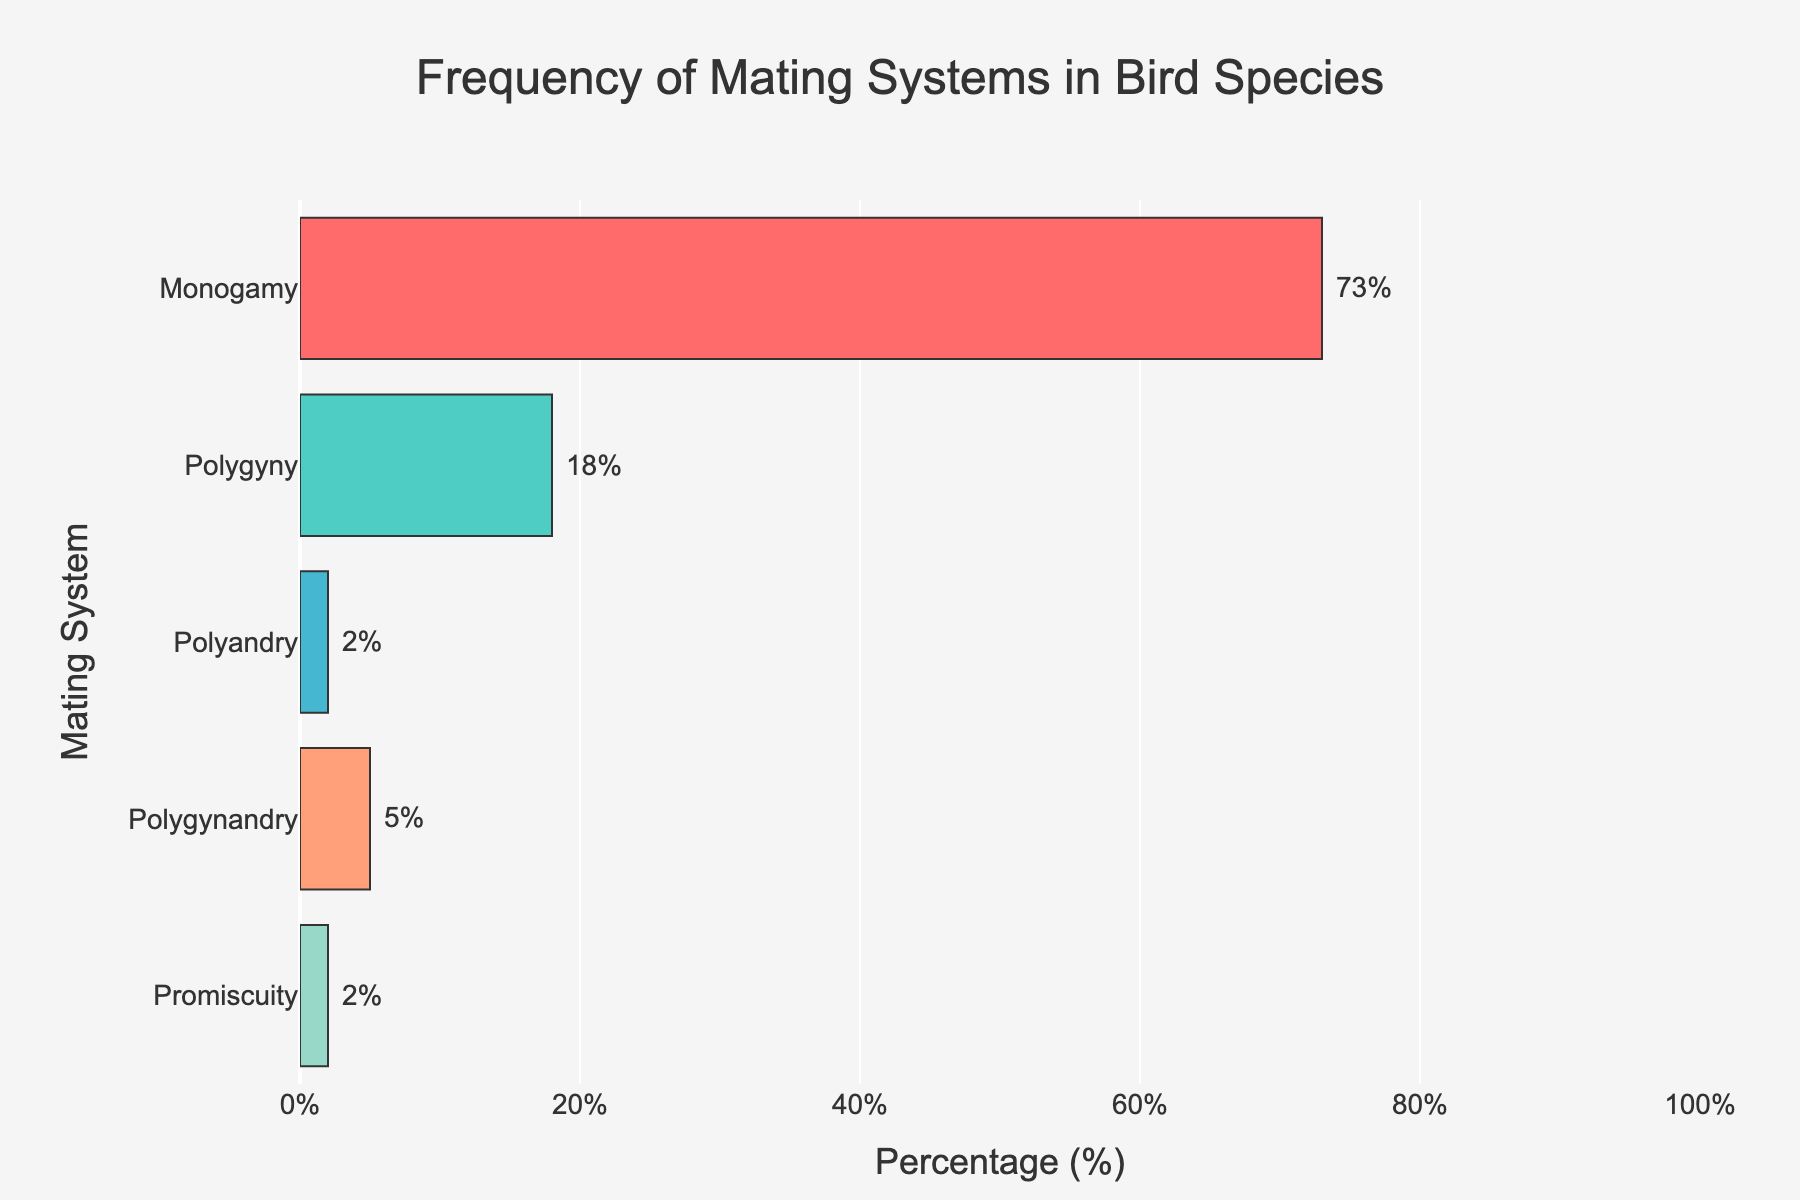what is the title of the plot? The title of the plot is positioned at the top and clearly states what the plot is about.
Answer: Frequency of Mating Systems in Bird Species What percentage of bird species practice monogamy? Locate the bar labeled "Monogamy" and check the percentage value on the x-axis or the annotation next to the bar.
Answer: 73% Which mating system has the lowest frequency? Identify the shortest bar or the one with the smallest percentage label.
Answer: Polyandry and Promiscuity How much higher is the percentage of monogamous species compared to polygynous species? Find the bars for monogamy and polygyny, and subtract the polygyny percentage from the monogamy percentage: 73% - 18%.
Answer: 55% What is the total percentage of species that do not practice monogamy? Sum the percentages of polygyny, polyandry, polygynandry, and promiscuity: 18% + 2% + 5% + 2%.
Answer: 27% Which mating system has the second-highest frequency? After identifying the monogamy bar as the highest, find the next tallest bar.
Answer: Polygyny What is the combined frequency of polyandry and promiscuity? Add the percentages for polyandry and promiscuity: 2% + 2%.
Answer: 4% How many mating systems are represented in the plot? Count the different bars in the plot to determine the number of unique mating systems.
Answer: 5 Is there a mating system practiced by at least 70% of bird species? Check if any bar has a percentage value equal to or greater than 70%.
Answer: Yes, monogamy Are there any mating systems with equal frequency? If so, which ones? Compare the heights and annotated values of the bars to find any with equal percentages.
Answer: Yes, Polyandry and Promiscuity 